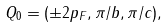<formula> <loc_0><loc_0><loc_500><loc_500>Q _ { 0 } = ( \pm 2 p _ { F } , \pi / b , \pi / c ) ,</formula> 